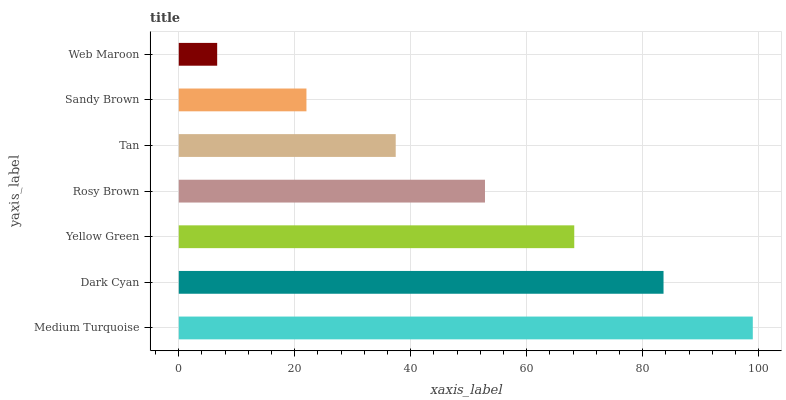Is Web Maroon the minimum?
Answer yes or no. Yes. Is Medium Turquoise the maximum?
Answer yes or no. Yes. Is Dark Cyan the minimum?
Answer yes or no. No. Is Dark Cyan the maximum?
Answer yes or no. No. Is Medium Turquoise greater than Dark Cyan?
Answer yes or no. Yes. Is Dark Cyan less than Medium Turquoise?
Answer yes or no. Yes. Is Dark Cyan greater than Medium Turquoise?
Answer yes or no. No. Is Medium Turquoise less than Dark Cyan?
Answer yes or no. No. Is Rosy Brown the high median?
Answer yes or no. Yes. Is Rosy Brown the low median?
Answer yes or no. Yes. Is Web Maroon the high median?
Answer yes or no. No. Is Web Maroon the low median?
Answer yes or no. No. 